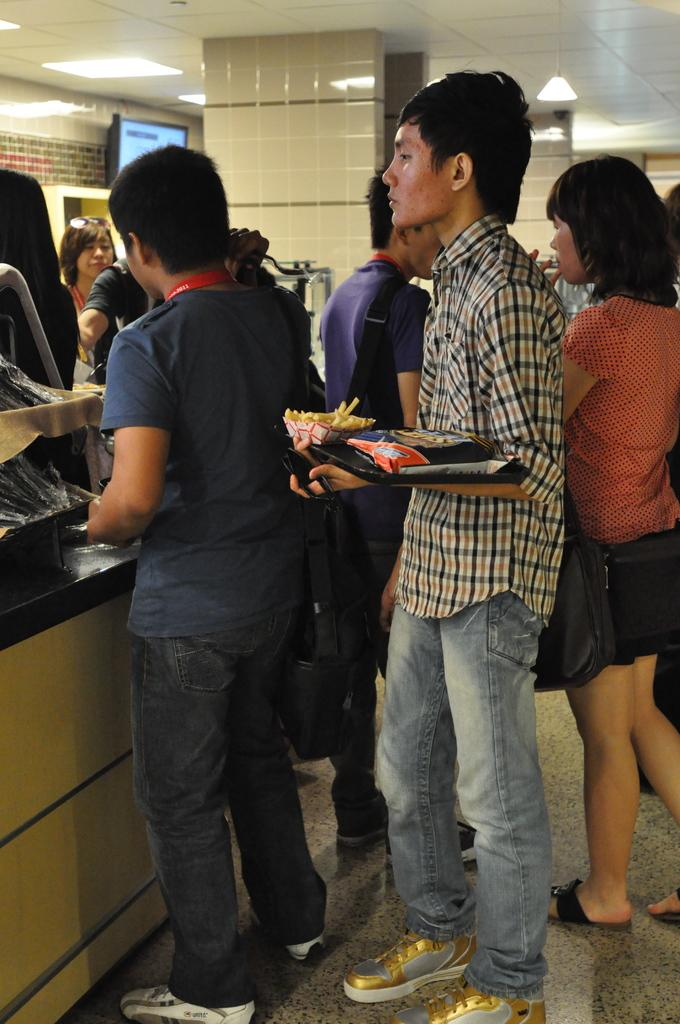How many people are present in the image? There are many people in the image. What is one person holding in the image? One person is holding a packet. What architectural feature can be seen in the image? There are pillars in the image. What type of lighting is present in the image? There are lights on the ceiling. Where is the television located in the image? The television is near a wall in the image. What type of bomb can be seen in the image? There is no bomb present in the image. Can you tell me how many tickets the person holding the packet has? The image does not provide information about the number of tickets the person holding the packet may have. 